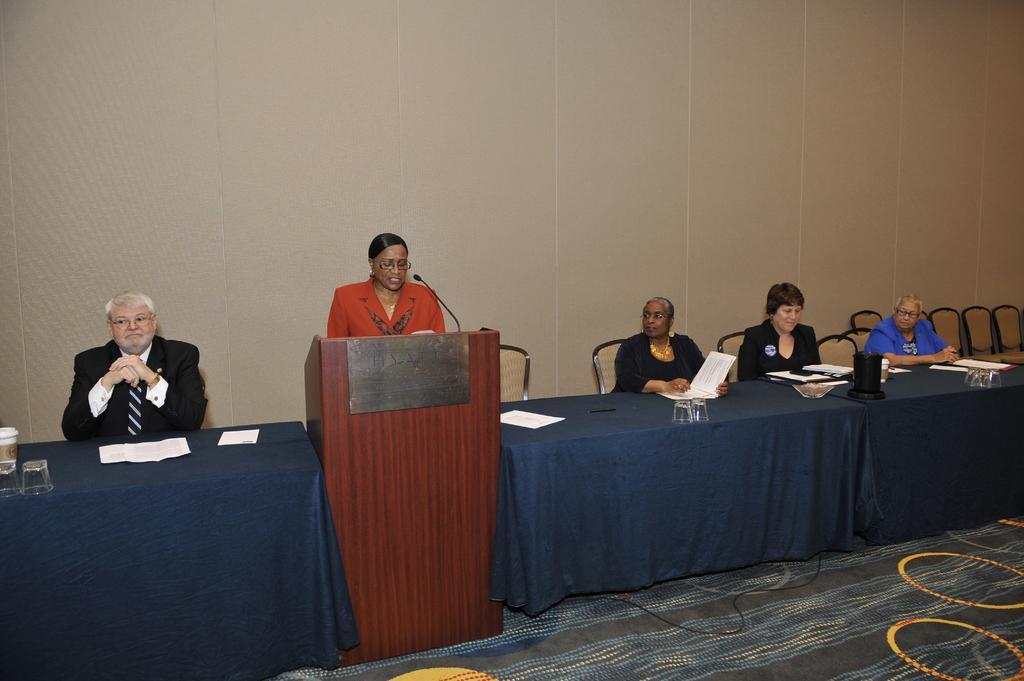Please provide a concise description of this image. In this picture we can see woman standing at podium and talking on mic and beside to her we can see three woman sitting on chair and on this side man sitting and in front of them there is table and on table we can see glasses, papers and in background we can see wall. 